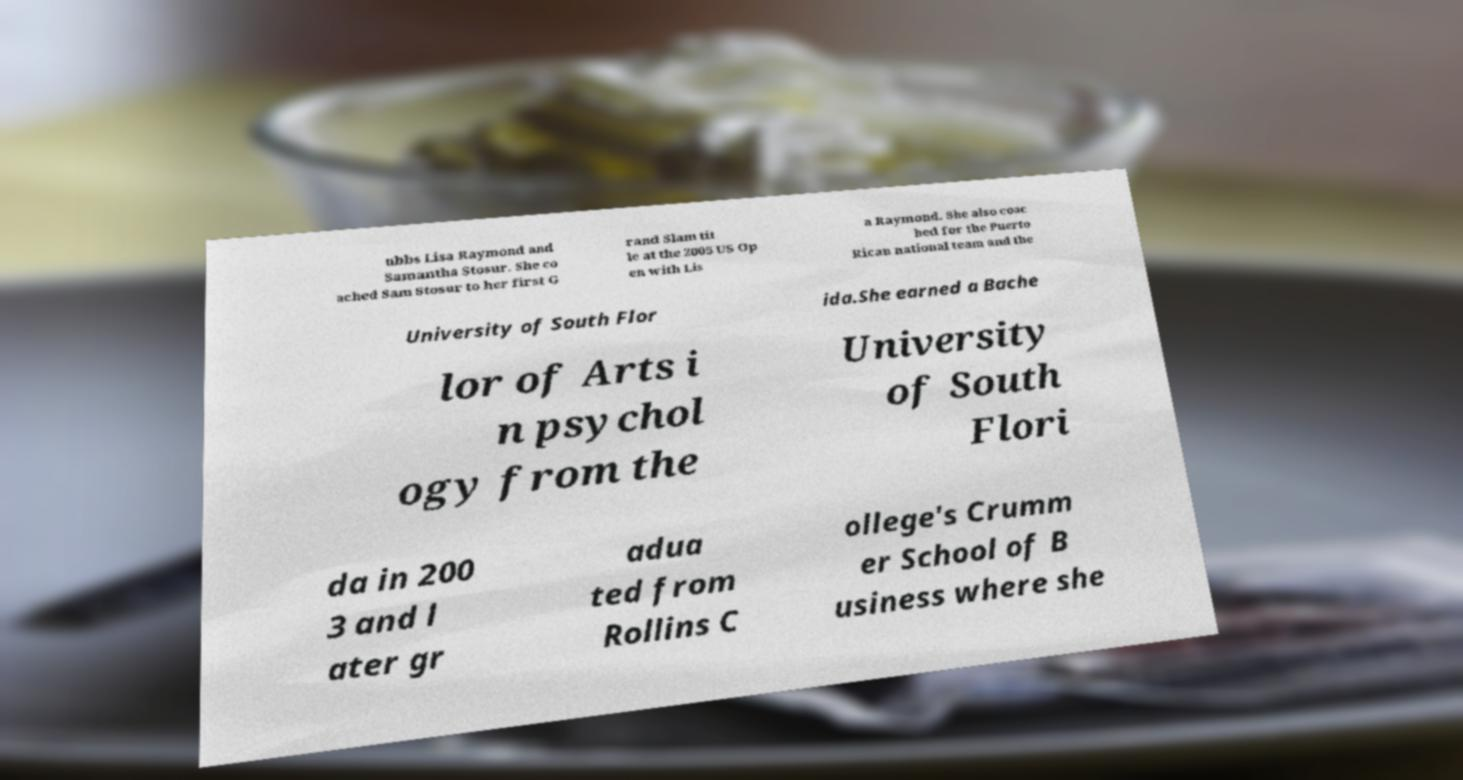For documentation purposes, I need the text within this image transcribed. Could you provide that? ubbs Lisa Raymond and Samantha Stosur. She co ached Sam Stosur to her first G rand Slam tit le at the 2005 US Op en with Lis a Raymond. She also coac hed for the Puerto Rican national team and the University of South Flor ida.She earned a Bache lor of Arts i n psychol ogy from the University of South Flori da in 200 3 and l ater gr adua ted from Rollins C ollege's Crumm er School of B usiness where she 